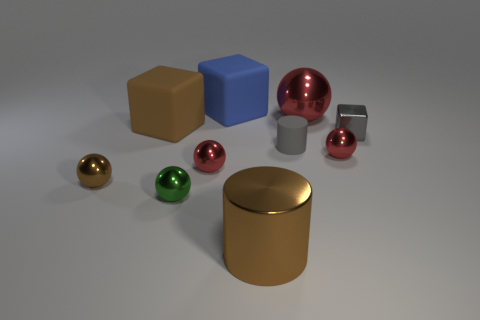How many red spheres must be subtracted to get 1 red spheres? 2 Subtract all gray cylinders. How many red spheres are left? 3 Subtract all small balls. How many balls are left? 1 Subtract all brown balls. How many balls are left? 4 Subtract 1 balls. How many balls are left? 4 Subtract all cyan balls. Subtract all green cylinders. How many balls are left? 5 Subtract all cylinders. How many objects are left? 8 Subtract all small cyan spheres. Subtract all brown rubber things. How many objects are left? 9 Add 7 large brown blocks. How many large brown blocks are left? 8 Add 4 small red metal objects. How many small red metal objects exist? 6 